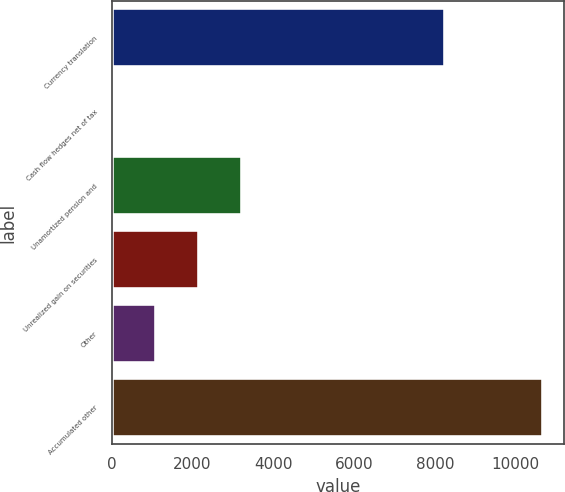<chart> <loc_0><loc_0><loc_500><loc_500><bar_chart><fcel>Currency translation<fcel>Cash flow hedges net of tax<fcel>Unamortized pension and<fcel>Unrealized gain on securities<fcel>Other<fcel>Accumulated other<nl><fcel>8255<fcel>34<fcel>3224.5<fcel>2161<fcel>1097.5<fcel>10669<nl></chart> 